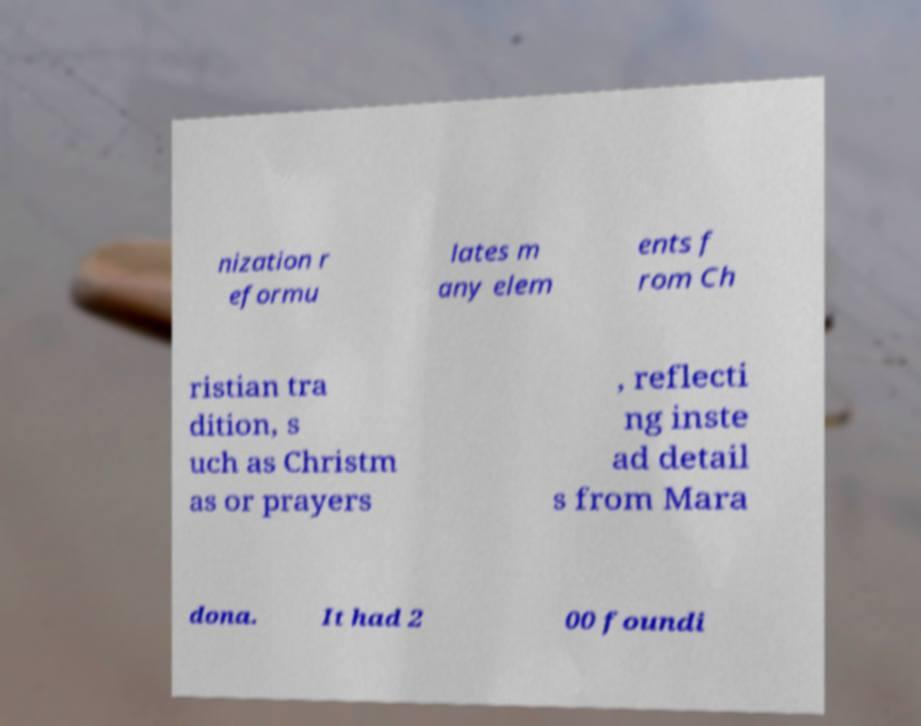Can you accurately transcribe the text from the provided image for me? nization r eformu lates m any elem ents f rom Ch ristian tra dition, s uch as Christm as or prayers , reflecti ng inste ad detail s from Mara dona. It had 2 00 foundi 